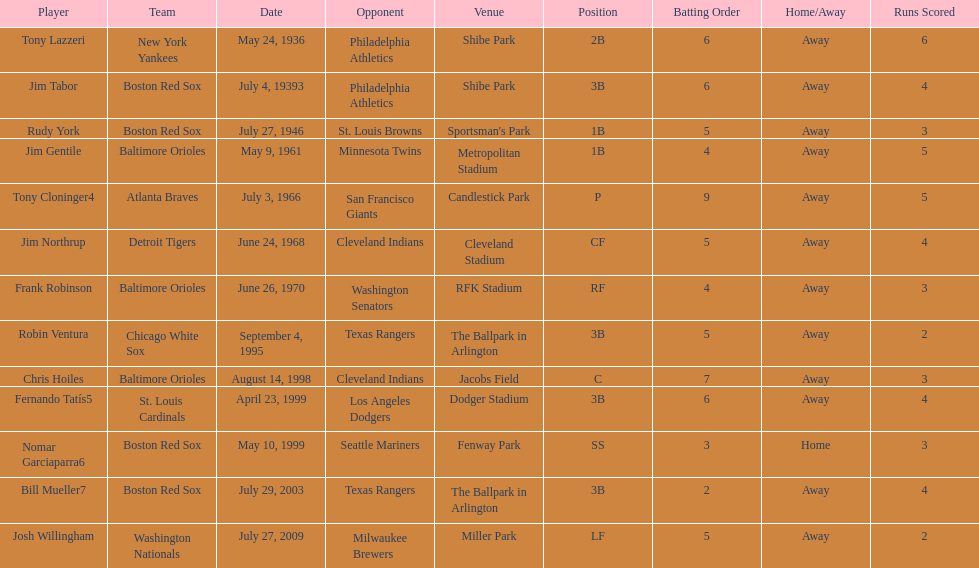What was the name of the last person to accomplish this up to date? Josh Willingham. 